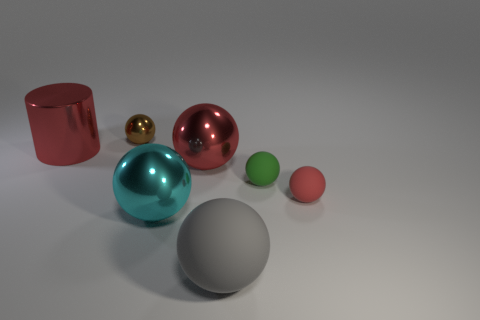There is a thing behind the big red cylinder; what is it made of? The object behind the big red cylinder appears to be a small golden sphere, which looks like it could be made of a polished metal, such as brass or gold, giving it a reflective surface and a lustrous finish. 